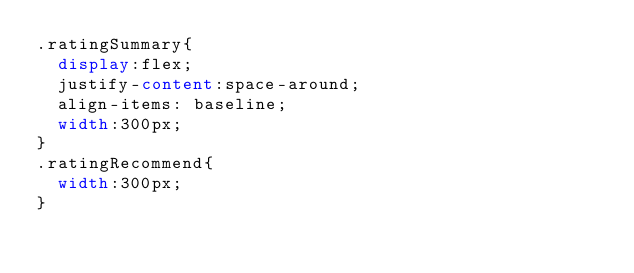<code> <loc_0><loc_0><loc_500><loc_500><_CSS_>.ratingSummary{
  display:flex;
  justify-content:space-around;
  align-items: baseline;
  width:300px;
}
.ratingRecommend{
  width:300px;
}</code> 